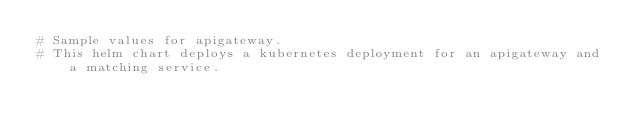Convert code to text. <code><loc_0><loc_0><loc_500><loc_500><_YAML_># Sample values for apigateway.
# This helm chart deploys a kubernetes deployment for an apigateway and a matching service.</code> 